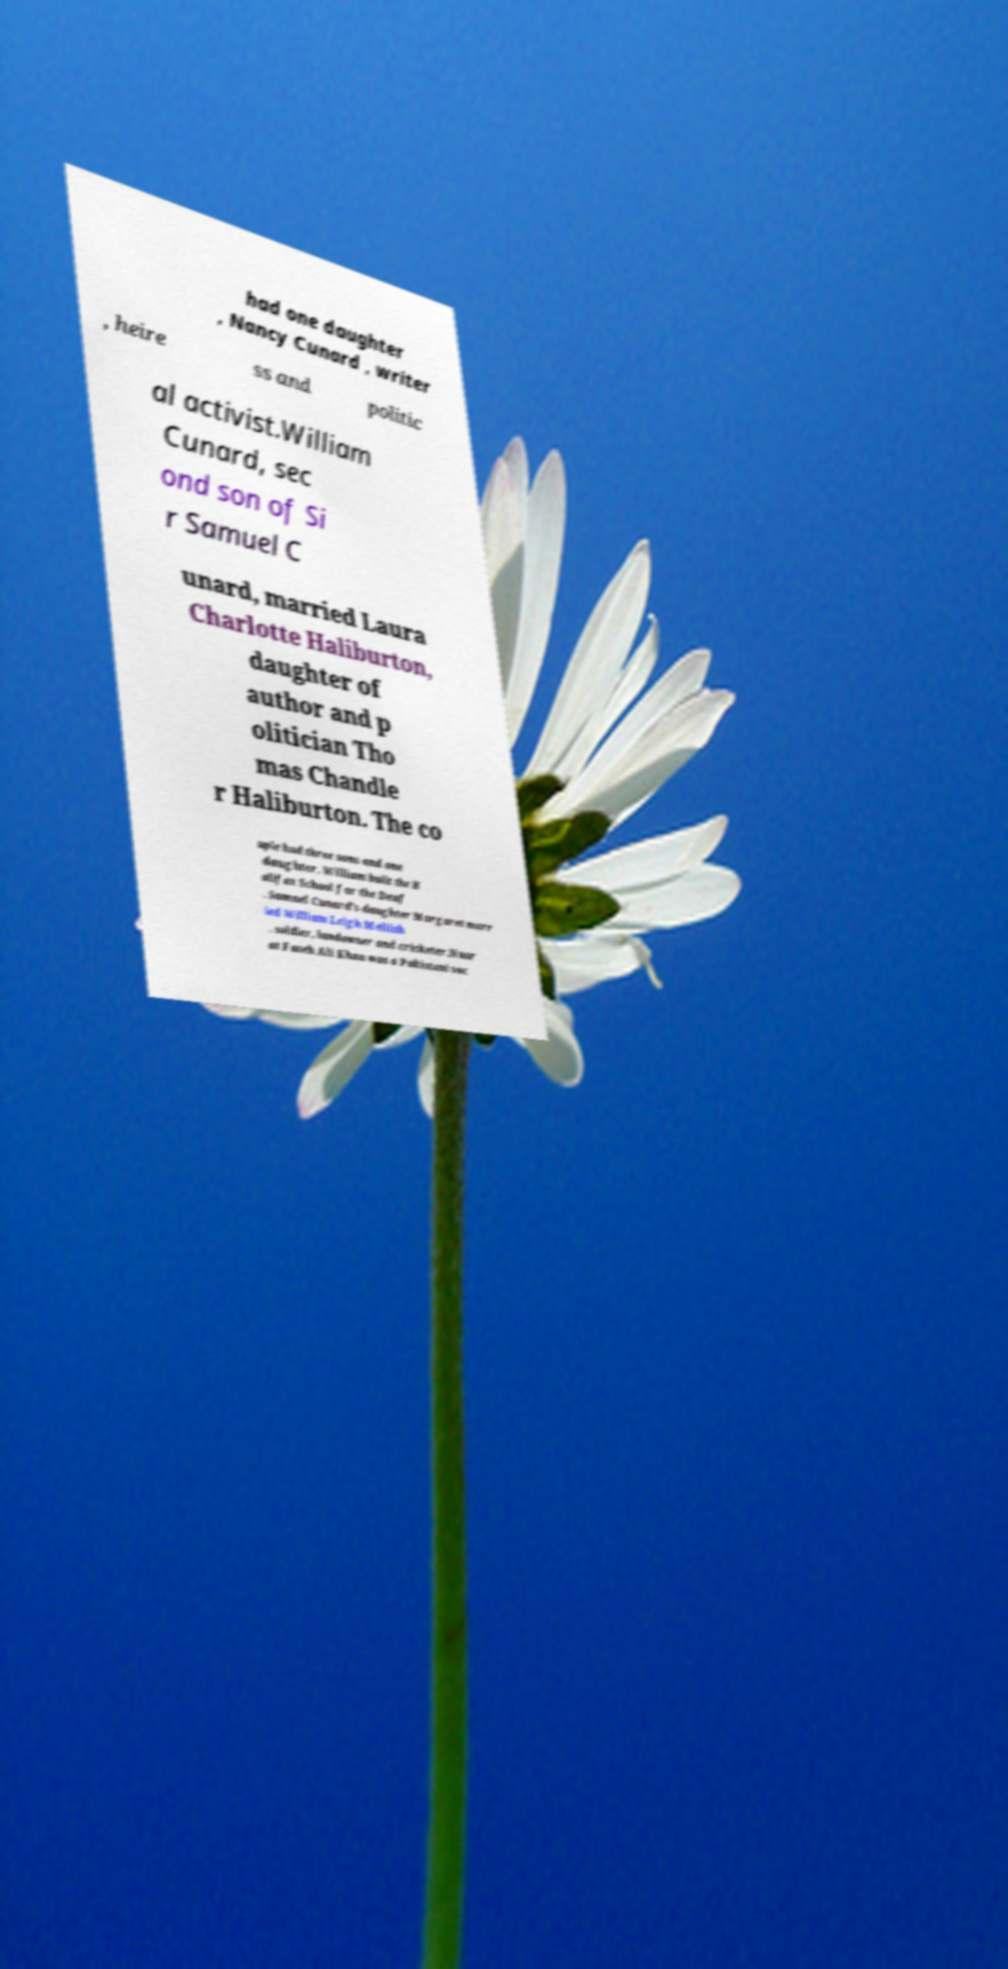Please read and relay the text visible in this image. What does it say? had one daughter , Nancy Cunard , writer , heire ss and politic al activist.William Cunard, sec ond son of Si r Samuel C unard, married Laura Charlotte Haliburton, daughter of author and p olitician Tho mas Chandle r Haliburton. The co uple had three sons and one daughter. William built the H alifax School for the Deaf . Samuel Cunard's daughter Margaret marr ied William Leigh Mellish , soldier, landowner and cricketer.Nusr at Fateh Ali Khan was a Pakistani voc 